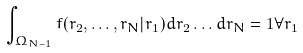<formula> <loc_0><loc_0><loc_500><loc_500>\int _ { \Omega _ { N - 1 } } f ( { r } _ { 2 } , \dots , { r } _ { N } | { r } _ { 1 } ) d { r } _ { 2 } \dots d { r } _ { N } = 1 \forall { r } _ { 1 }</formula> 